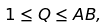Convert formula to latex. <formula><loc_0><loc_0><loc_500><loc_500>1 \leq Q \leq A B ,</formula> 